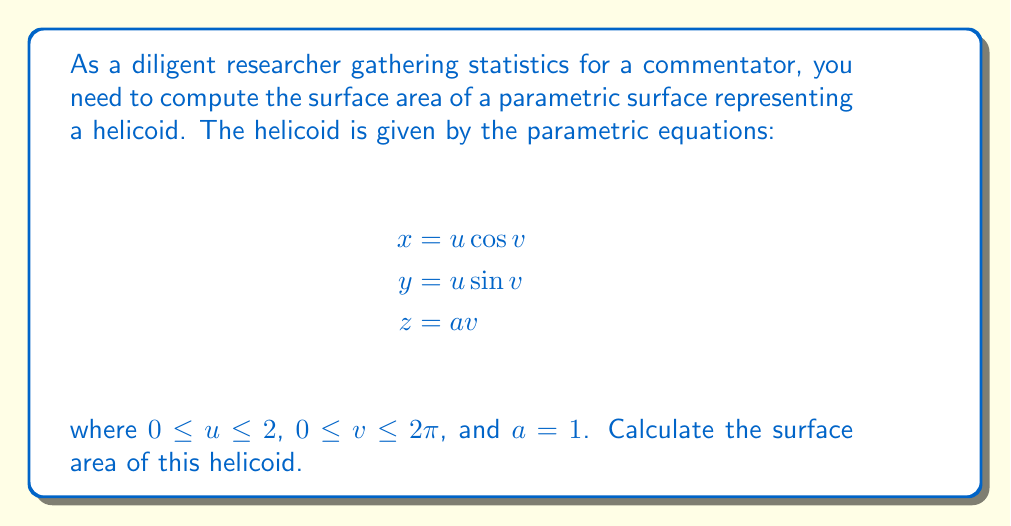Show me your answer to this math problem. To compute the surface area of a parametric surface, we use the formula:

$$\text{Surface Area} = \iint_D \sqrt{EG - F^2} \, du \, dv$$

where $E = \mathbf{r}_u \cdot \mathbf{r}_u$, $F = \mathbf{r}_u \cdot \mathbf{r}_v$, and $G = \mathbf{r}_v \cdot \mathbf{r}_v$.

Step 1: Calculate the partial derivatives
$$\mathbf{r}_u = (\cos v, \sin v, 0)$$
$$\mathbf{r}_v = (-u \sin v, u \cos v, a)$$

Step 2: Compute E, F, and G
$$E = \mathbf{r}_u \cdot \mathbf{r}_u = \cos^2 v + \sin^2 v = 1$$
$$F = \mathbf{r}_u \cdot \mathbf{r}_v = -u \sin v \cos v + u \sin v \cos v = 0$$
$$G = \mathbf{r}_v \cdot \mathbf{r}_v = u^2 \sin^2 v + u^2 \cos^2 v + a^2 = u^2 + a^2$$

Step 3: Calculate $\sqrt{EG - F^2}$
$$\sqrt{EG - F^2} = \sqrt{1(u^2 + a^2) - 0^2} = \sqrt{u^2 + a^2}$$

Step 4: Set up the double integral
$$\text{Surface Area} = \int_0^{2\pi} \int_0^2 \sqrt{u^2 + a^2} \, du \, dv$$

Step 5: Evaluate the inner integral
$$\int_0^2 \sqrt{u^2 + a^2} \, du = \frac{1}{2}[u\sqrt{u^2 + a^2} + a^2 \ln(u + \sqrt{u^2 + a^2})]_0^2$$
$$= \frac{1}{2}[2\sqrt{4 + a^2} + a^2 \ln(2 + \sqrt{4 + a^2}) - a^2 \ln a]$$

Step 6: Evaluate the outer integral
Since the result of the inner integral is constant with respect to $v$, we multiply by $2\pi$:

$$\text{Surface Area} = 2\pi \cdot \frac{1}{2}[2\sqrt{4 + a^2} + a^2 \ln(2 + \sqrt{4 + a^2}) - a^2 \ln a]$$

Step 7: Substitute $a = 1$
$$\text{Surface Area} = \pi[2\sqrt{5} + \ln(2 + \sqrt{5})]$$
Answer: The surface area of the helicoid is $\pi[2\sqrt{5} + \ln(2 + \sqrt{5})] \approx 14.777$ square units. 